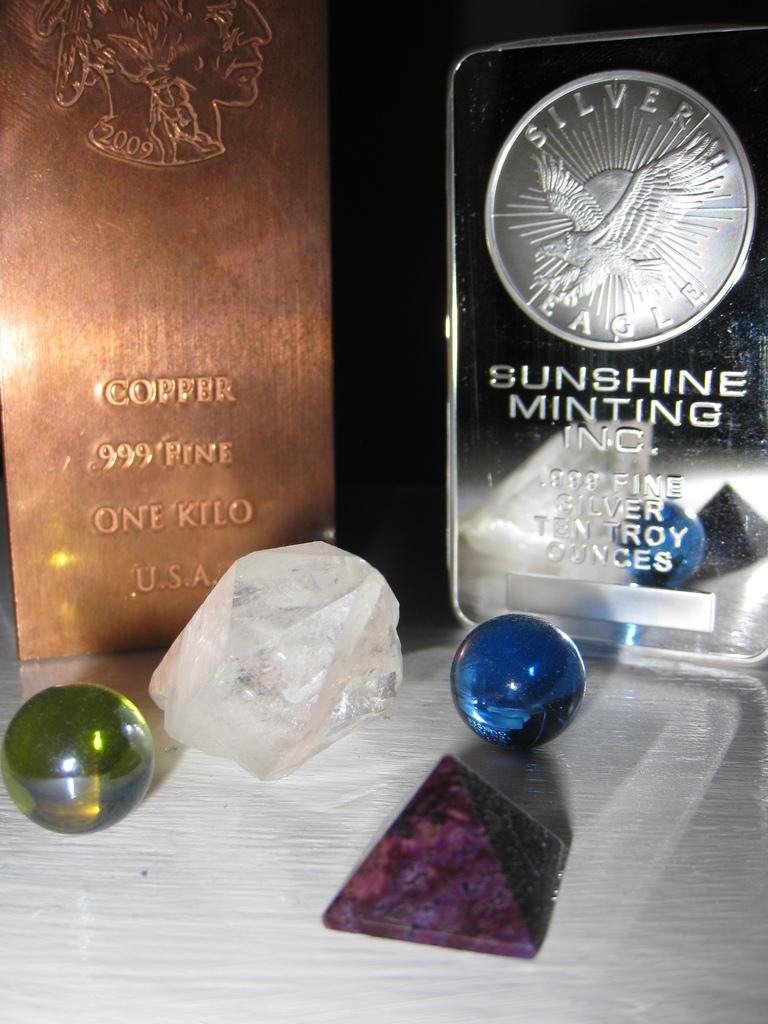<image>
Render a clear and concise summary of the photo. Some gems and a coin from Sunshine Minting Inc. 